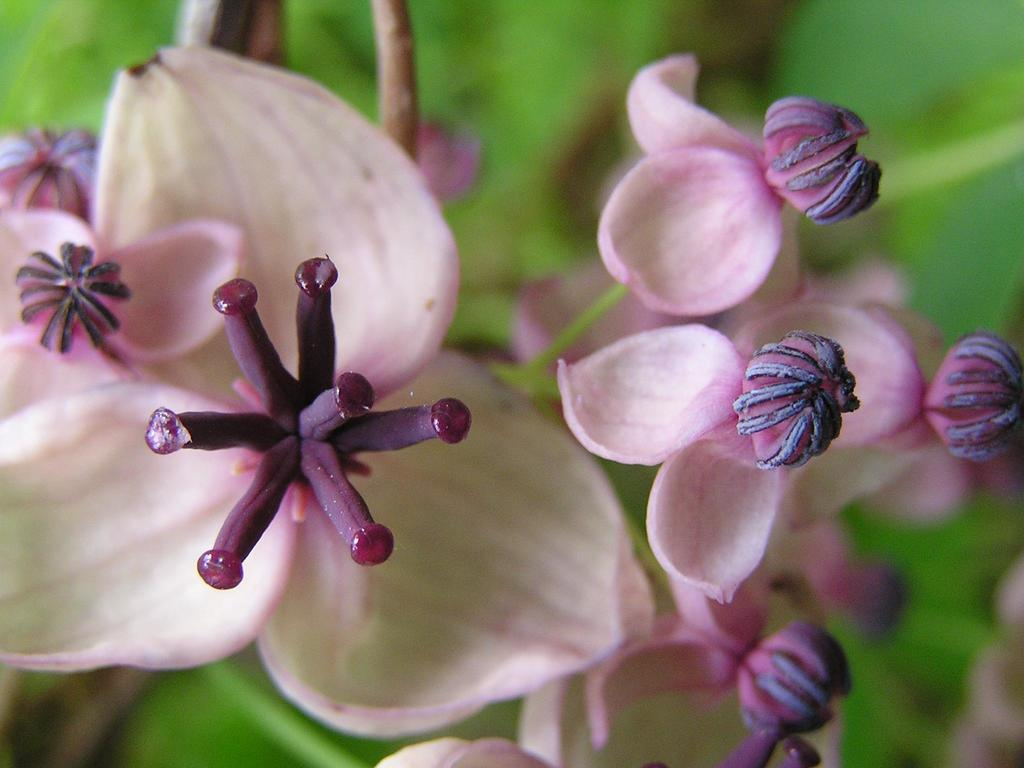What type of plant is present in the image? There are flowers in the image. What color are the petals of the flowers? The flowers have pink color petals. Are the flowers in the image fully bloomed? No, the flowers have buds, indicating they are not fully bloomed. What can be seen in the background of the image? There are leafs in the background of the image. What is the price of the chalk used to draw the flowers in the image? There is no chalk present in the image, and the flowers are not drawn but are real flowers. 